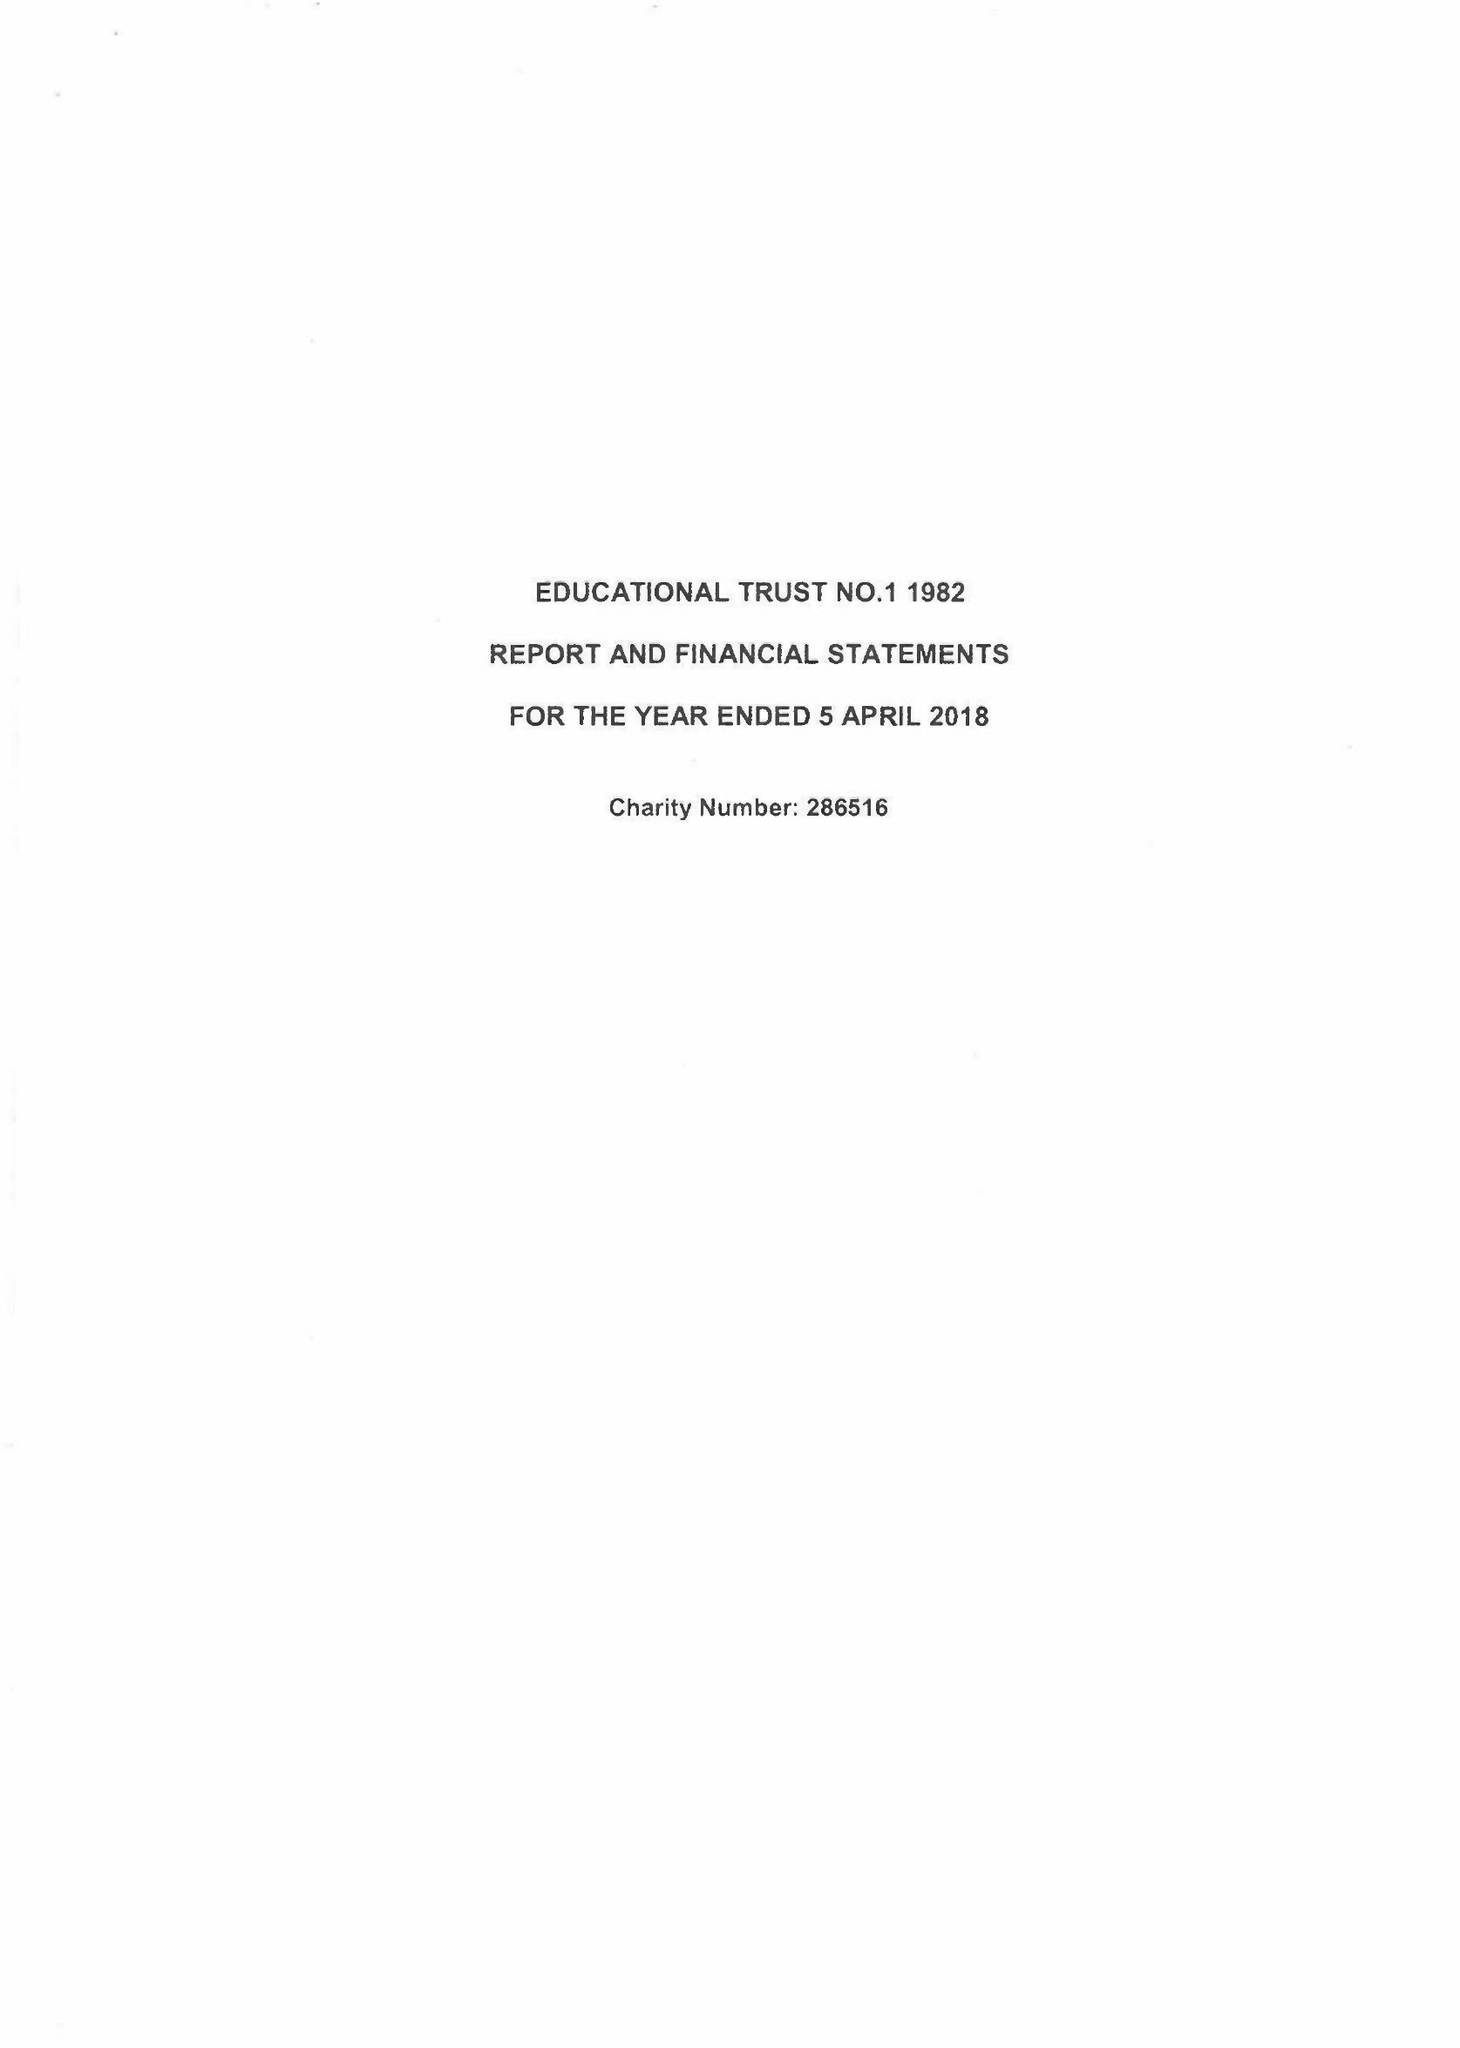What is the value for the spending_annually_in_british_pounds?
Answer the question using a single word or phrase. 138918.00 